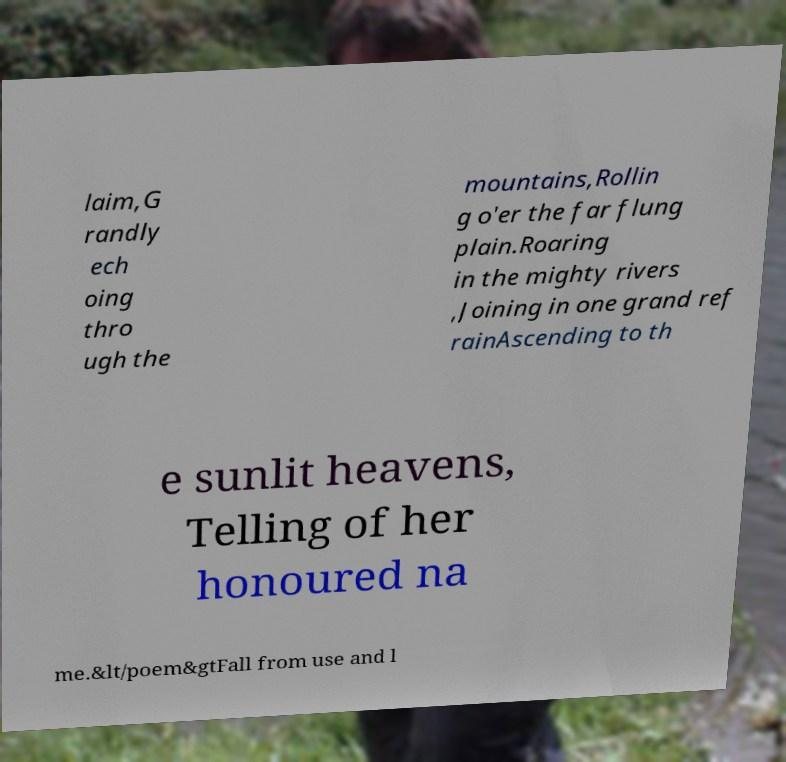Please identify and transcribe the text found in this image. laim,G randly ech oing thro ugh the mountains,Rollin g o'er the far flung plain.Roaring in the mighty rivers ,Joining in one grand ref rainAscending to th e sunlit heavens, Telling of her honoured na me.&lt/poem&gtFall from use and l 